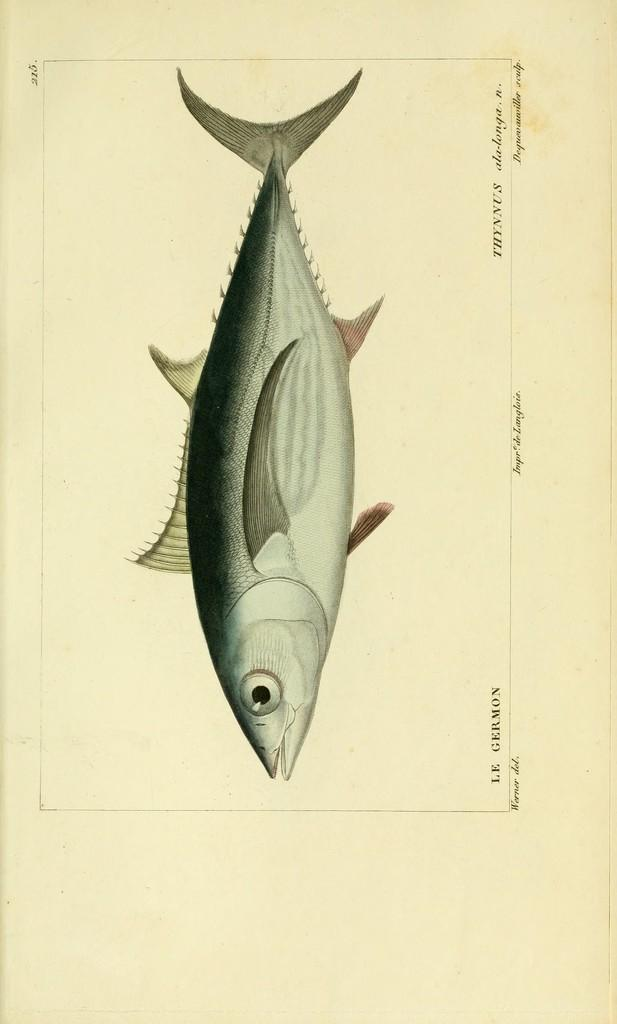What is the main object in the image? There is a white paper in the image. What is depicted on the paper? A fish is drawn on the paper. Are there any words or letters on the paper? Yes, there is text written on the paper. What type of brick is used to build the house in the image? There is no house or brick present in the image; it only features a white paper with a fish drawing and text. How does the person in the image care for the fish? There is no person present in the image, and the fish is a drawing on the paper, so it cannot be cared for. 